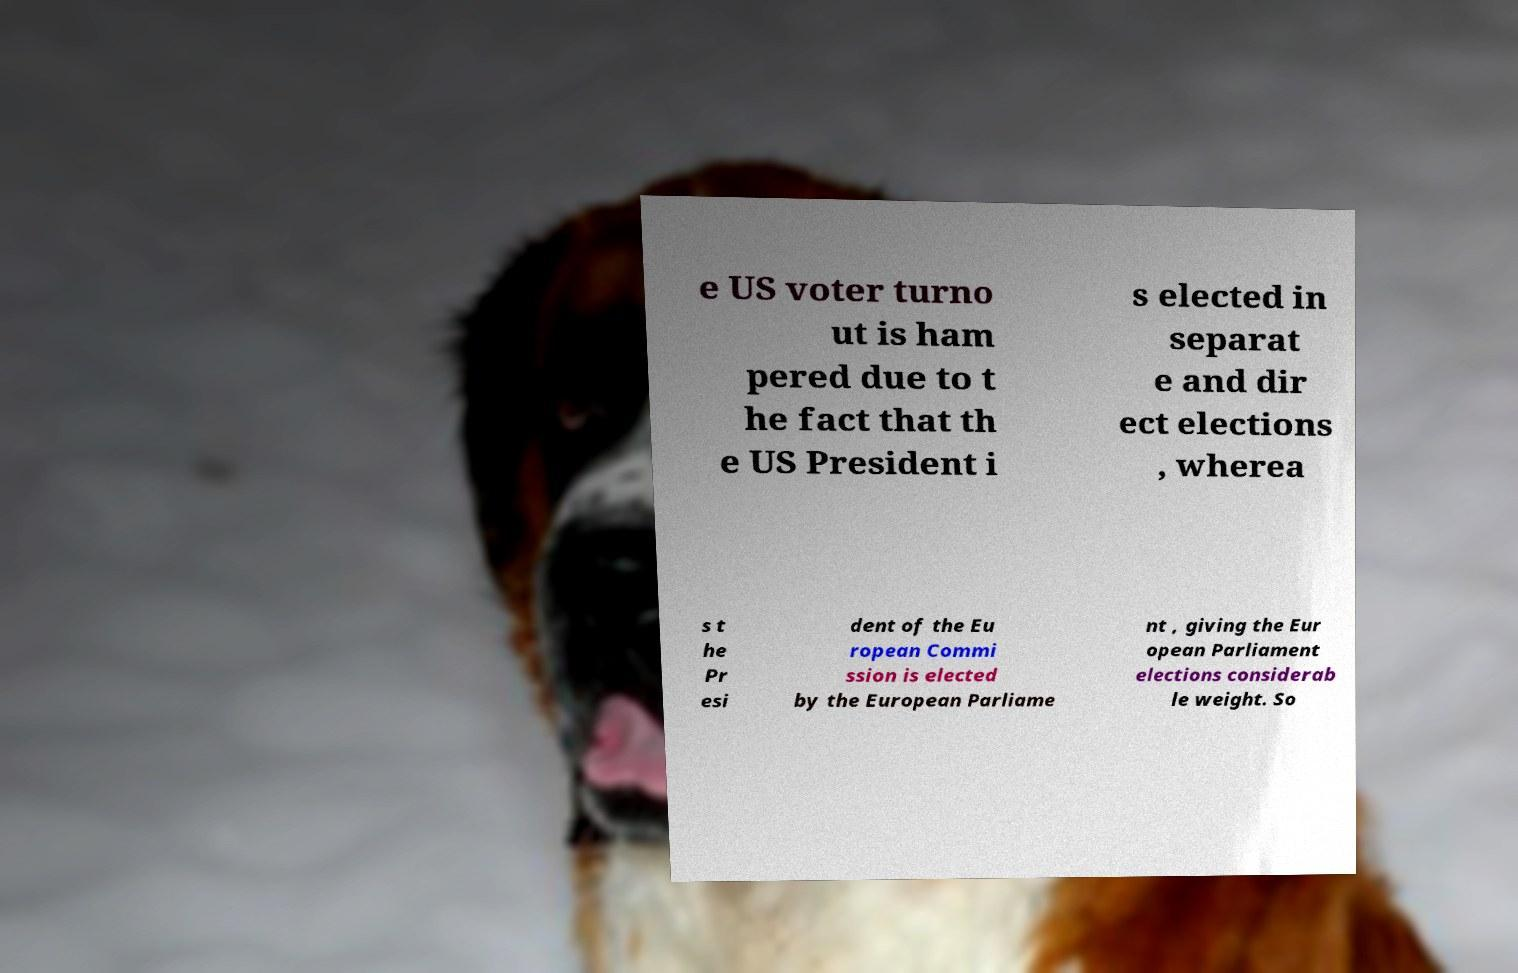For documentation purposes, I need the text within this image transcribed. Could you provide that? e US voter turno ut is ham pered due to t he fact that th e US President i s elected in separat e and dir ect elections , wherea s t he Pr esi dent of the Eu ropean Commi ssion is elected by the European Parliame nt , giving the Eur opean Parliament elections considerab le weight. So 